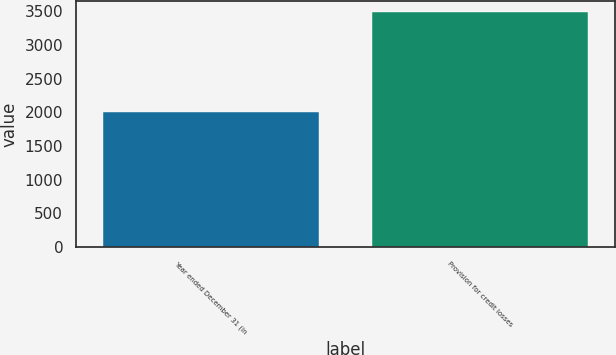Convert chart to OTSL. <chart><loc_0><loc_0><loc_500><loc_500><bar_chart><fcel>Year ended December 31 (in<fcel>Provision for credit losses<nl><fcel>2005<fcel>3483<nl></chart> 